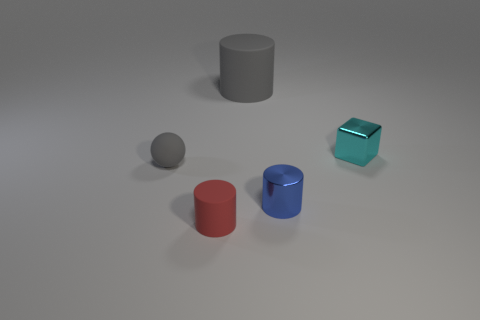There is a rubber ball that is the same color as the big cylinder; what size is it?
Offer a terse response. Small. What is the size of the gray cylinder that is made of the same material as the ball?
Your answer should be very brief. Large. Do the gray object that is on the left side of the big matte object and the rubber cylinder in front of the big gray matte thing have the same size?
Make the answer very short. Yes. What number of objects are either small cyan metallic things or blue shiny cylinders?
Your response must be concise. 2. What is the shape of the large matte object?
Make the answer very short. Cylinder. There is another red matte thing that is the same shape as the big rubber object; what is its size?
Provide a short and direct response. Small. Is there any other thing that has the same material as the tiny block?
Provide a succinct answer. Yes. How big is the gray thing that is behind the metal thing behind the blue thing?
Give a very brief answer. Large. Are there an equal number of small gray matte spheres that are behind the small blue thing and big purple spheres?
Keep it short and to the point. No. What number of other objects are there of the same color as the large matte cylinder?
Provide a short and direct response. 1. 